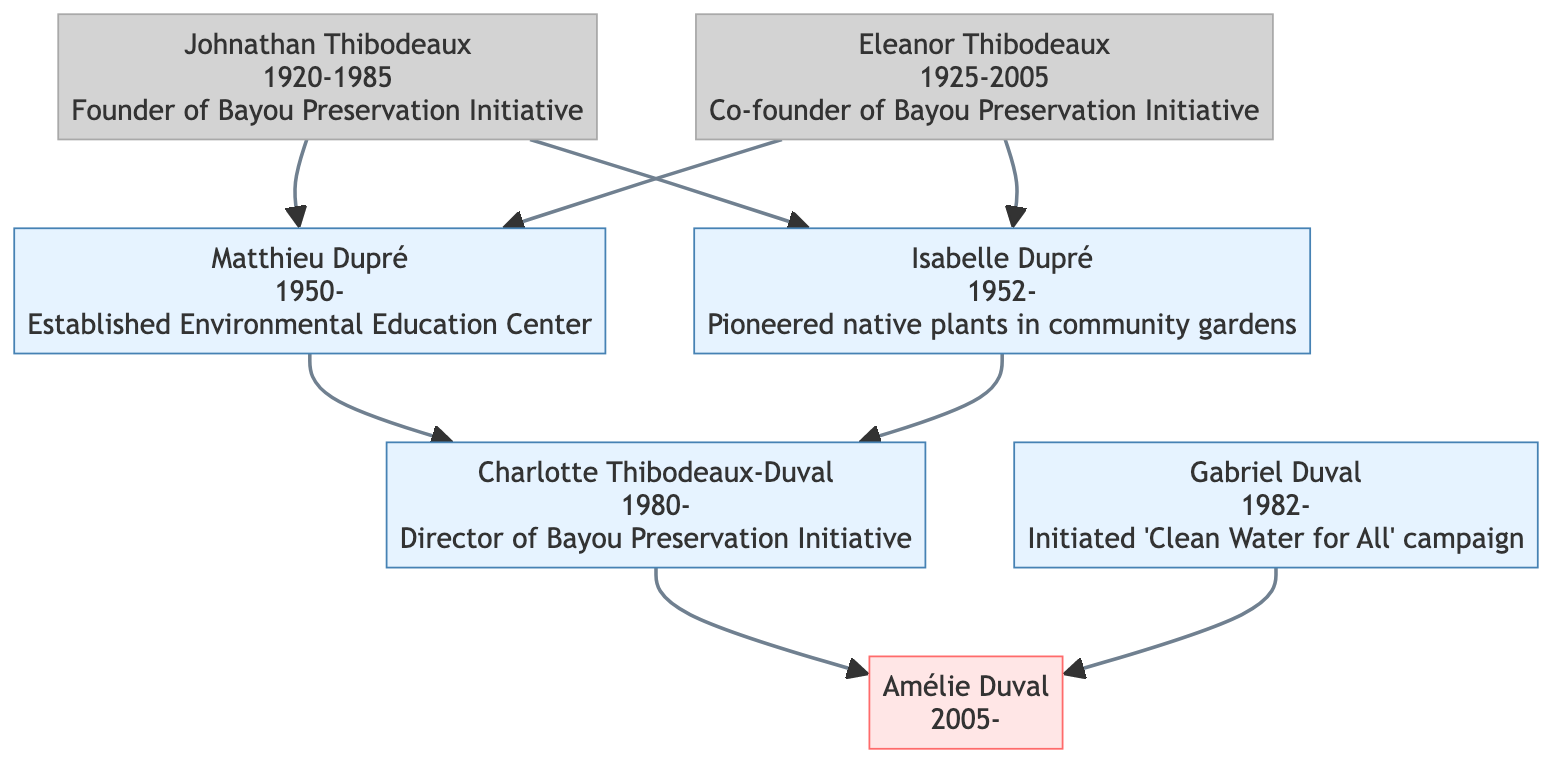What is the birth year of Johnathan Thibodeaux? The diagram indicates that Johnathan Thibodeaux was born in 1920, as his birth year is explicitly stated within his node in the diagram.
Answer: 1920 Who is the current director of the Bayou Preservation Initiative? The diagram clearly shows that Charlotte Thibodeaux-Duval is the current director, as indicated in her node under her significant contributions.
Answer: Charlotte Thibodeaux-Duval How many great grandparents are listed in the diagram? The diagram shows two individuals labeled as great grandparents: Johnathan Thibodeaux and Eleanor Thibodeaux, which can be counted from the diagram.
Answer: 2 What is the relationship between Matthieu Dupré and Charlotte Thibodeaux-Duval? Matthieu Dupré is a grandparent and Charlotte Thibodeaux-Duval is a parent; thus, the relationship is that Matthieu Dupré is the grandfather of Charlotte.
Answer: Grandparent Which advocate was born in 1952? By reviewing the nodes, it is clear that Isabelle Dupré was born in 1952, as indicated in her node in the diagram.
Answer: Isabelle Dupré What significant contribution did Eleanor Thibodeaux make in the 1980s? Eleanor Thibodeaux is noted for advocating for state legislation on coastal protection in the 1980s as listed in her node under significant contributions.
Answer: Advocated for state legislation on coastal protection How many living descendants are indicated in the diagram? The diagram displays four living individuals: Matthieu Dupré, Isabelle Dupré, Charlotte Thibodeaux-Duval, and Gabriel Duval. Counting these nodes gives the answer.
Answer: 4 Who is the child of Charlotte Thibodeaux-Duval? The diagram indicates that Amélie Duval is the child of Charlotte Thibodeaux-Duval, as shown in her node connected to Charlotte's node in the diagram.
Answer: Amélie Duval What organization did Gabriel Duval serve on the board of? Gabriel Duval's node states that he serves on the board of the Louisiana Environmental Action Network. Therefore, this organization is the answer.
Answer: Louisiana Environmental Action Network 